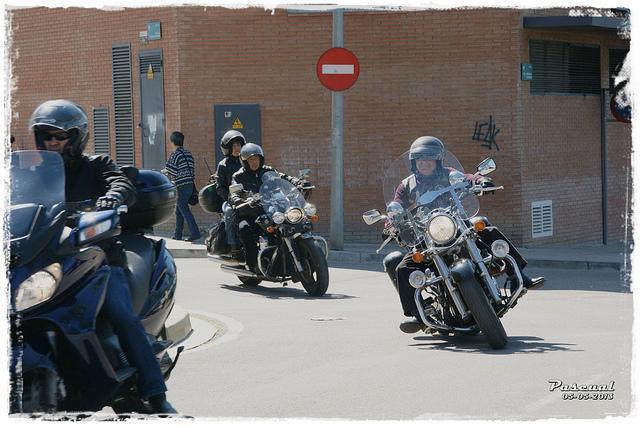How many motorcycles are in the picture?
Give a very brief answer. 3. How many people can you see?
Give a very brief answer. 3. 